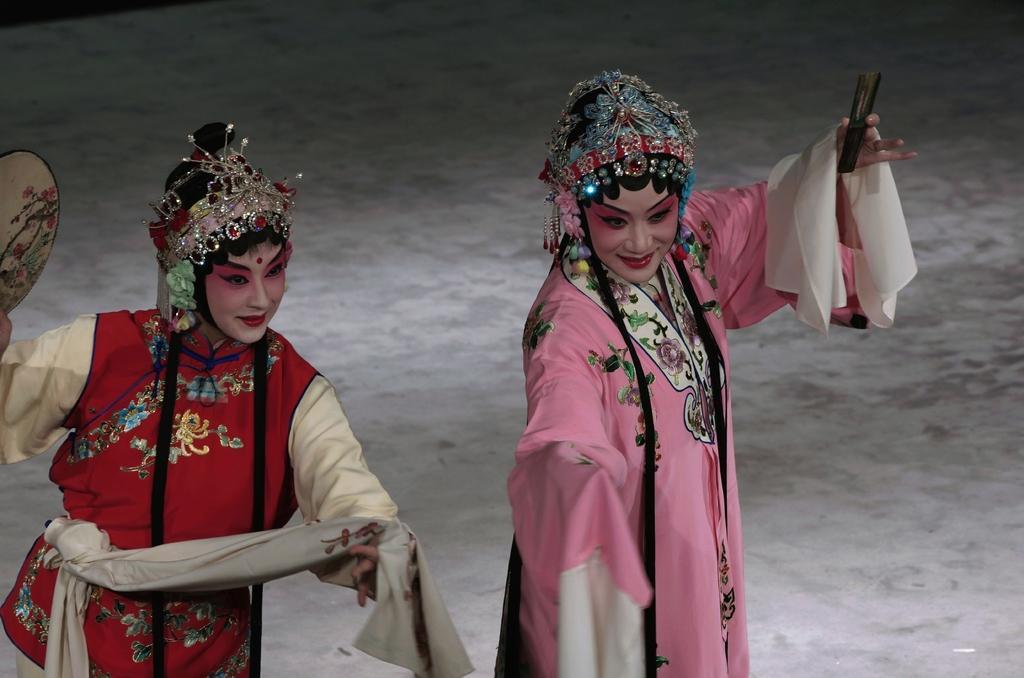Can you describe this image briefly? In this image there are two persons who are wearing the gowns of different colors. They are wearing the crowns. There is makeup to their faces. They are holding the sticks. On the left side there is a woman who is holding the plate. 